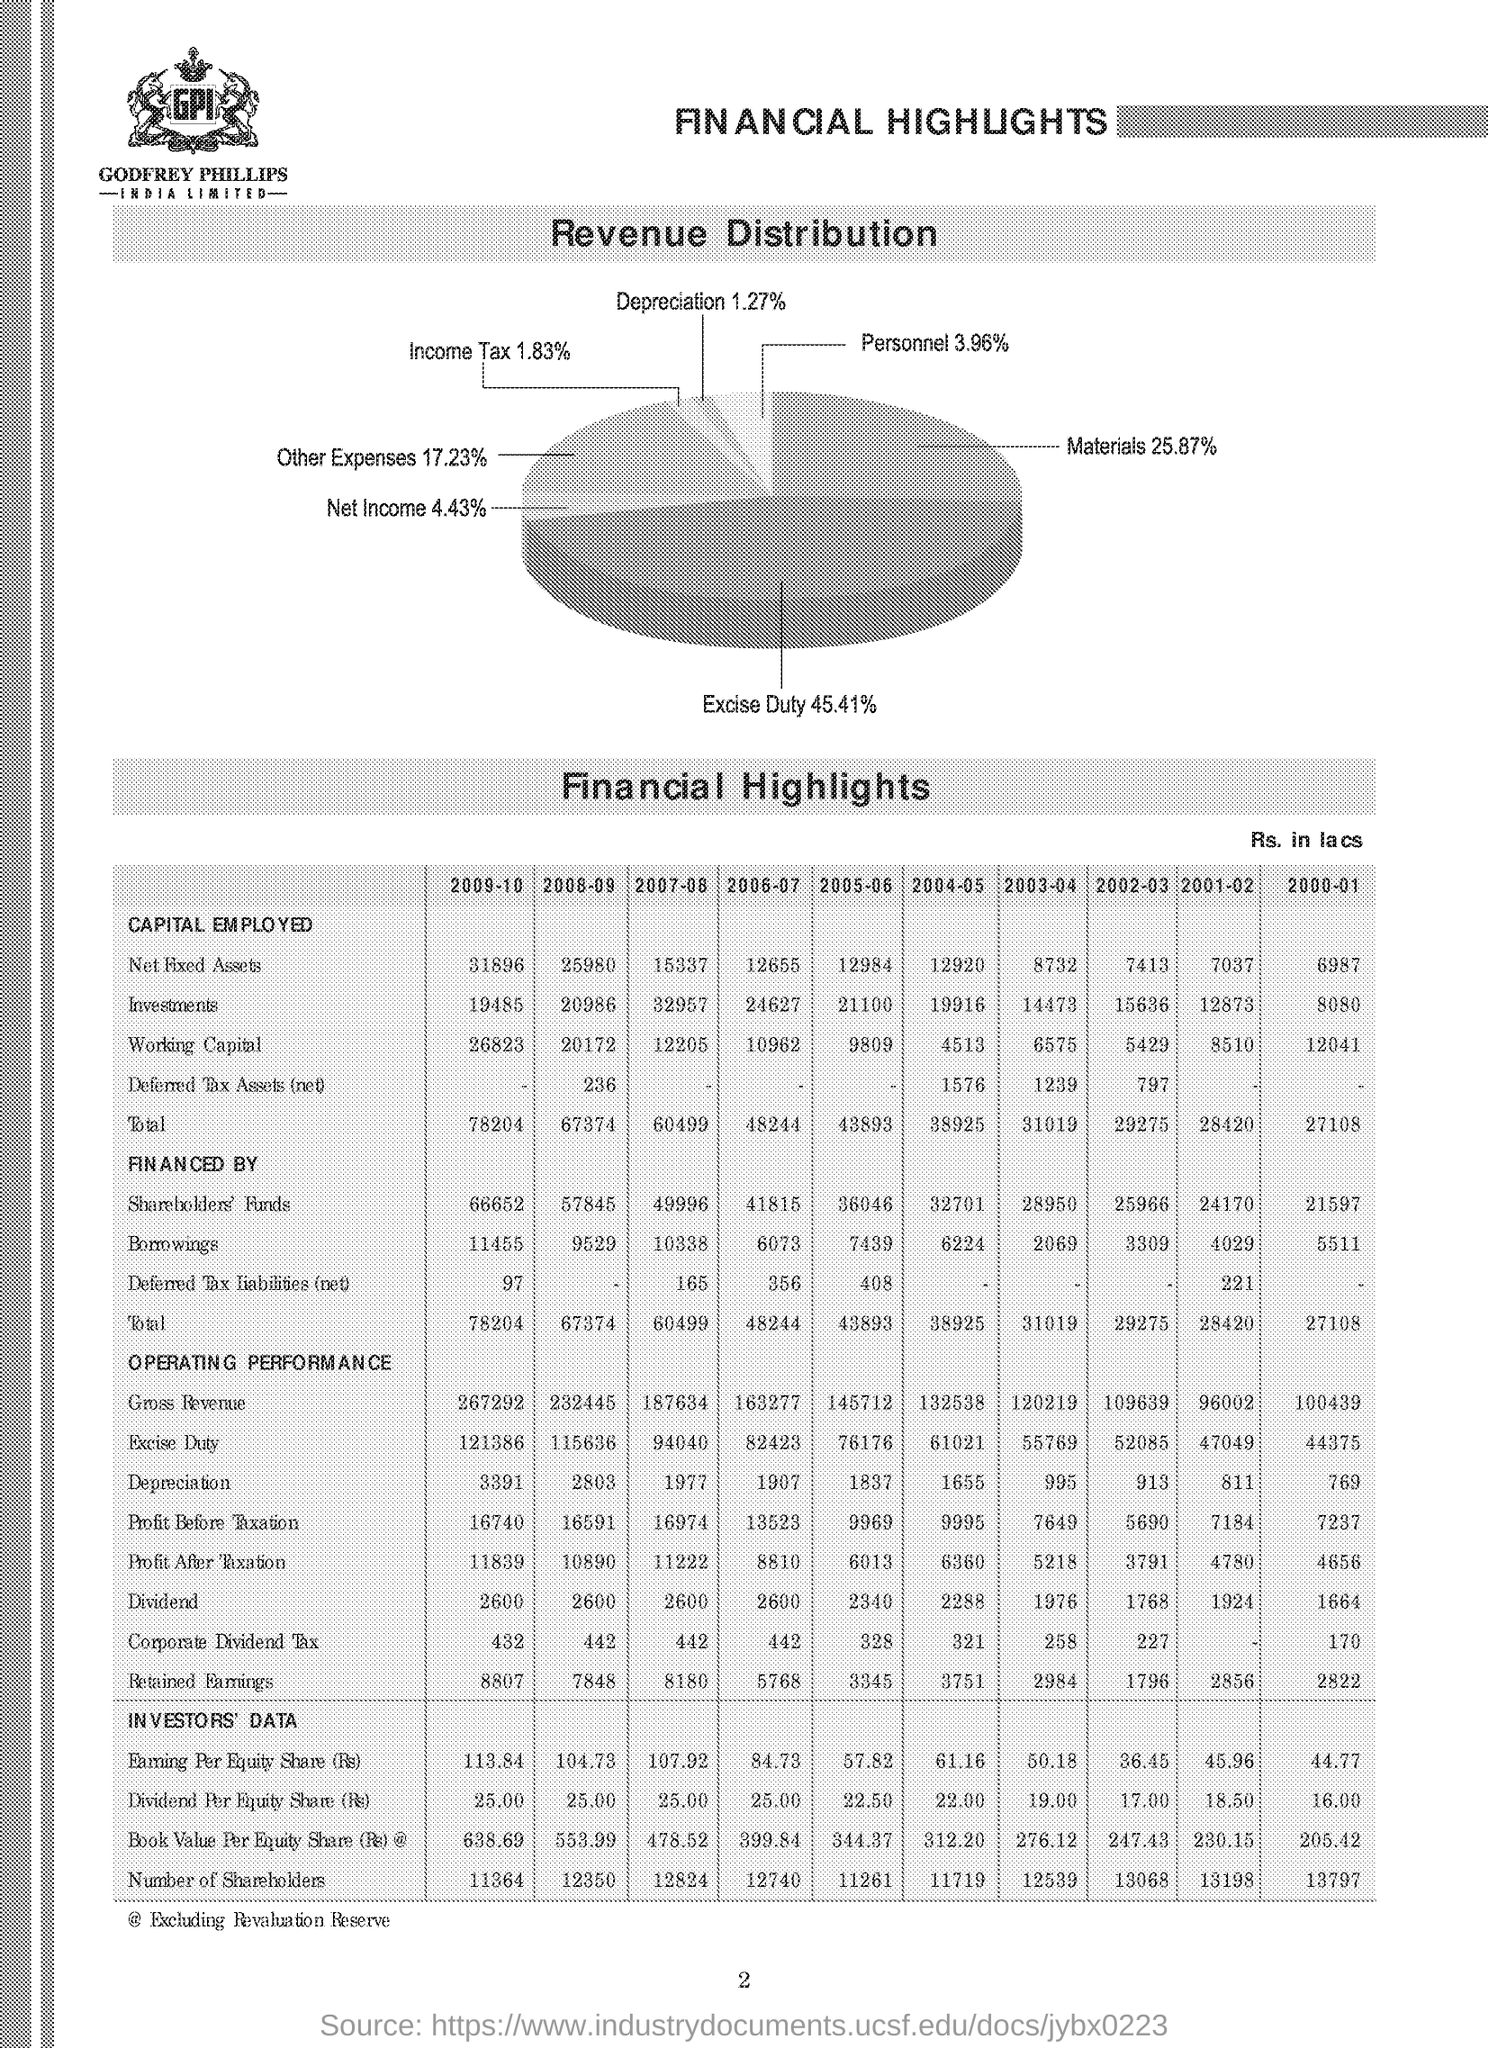what is the materials % in revenue distribution? Materials account for 25.87% of the revenue distribution in the pie chart. This segment is a significant part of the company's revenue structure, reflecting the costs associated with the raw materials required for their operations. 